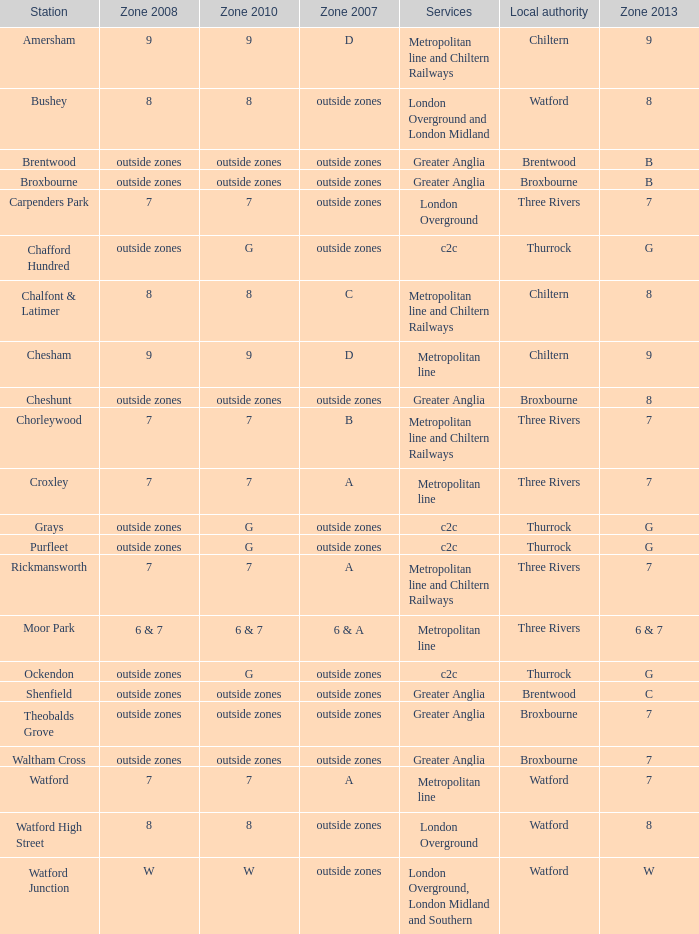I'm looking to parse the entire table for insights. Could you assist me with that? {'header': ['Station', 'Zone 2008', 'Zone 2010', 'Zone 2007', 'Services', 'Local authority', 'Zone 2013'], 'rows': [['Amersham', '9', '9', 'D', 'Metropolitan line and Chiltern Railways', 'Chiltern', '9'], ['Bushey', '8', '8', 'outside zones', 'London Overground and London Midland', 'Watford', '8'], ['Brentwood', 'outside zones', 'outside zones', 'outside zones', 'Greater Anglia', 'Brentwood', 'B'], ['Broxbourne', 'outside zones', 'outside zones', 'outside zones', 'Greater Anglia', 'Broxbourne', 'B'], ['Carpenders Park', '7', '7', 'outside zones', 'London Overground', 'Three Rivers', '7'], ['Chafford Hundred', 'outside zones', 'G', 'outside zones', 'c2c', 'Thurrock', 'G'], ['Chalfont & Latimer', '8', '8', 'C', 'Metropolitan line and Chiltern Railways', 'Chiltern', '8'], ['Chesham', '9', '9', 'D', 'Metropolitan line', 'Chiltern', '9'], ['Cheshunt', 'outside zones', 'outside zones', 'outside zones', 'Greater Anglia', 'Broxbourne', '8'], ['Chorleywood', '7', '7', 'B', 'Metropolitan line and Chiltern Railways', 'Three Rivers', '7'], ['Croxley', '7', '7', 'A', 'Metropolitan line', 'Three Rivers', '7'], ['Grays', 'outside zones', 'G', 'outside zones', 'c2c', 'Thurrock', 'G'], ['Purfleet', 'outside zones', 'G', 'outside zones', 'c2c', 'Thurrock', 'G'], ['Rickmansworth', '7', '7', 'A', 'Metropolitan line and Chiltern Railways', 'Three Rivers', '7'], ['Moor Park', '6 & 7', '6 & 7', '6 & A', 'Metropolitan line', 'Three Rivers', '6 & 7'], ['Ockendon', 'outside zones', 'G', 'outside zones', 'c2c', 'Thurrock', 'G'], ['Shenfield', 'outside zones', 'outside zones', 'outside zones', 'Greater Anglia', 'Brentwood', 'C'], ['Theobalds Grove', 'outside zones', 'outside zones', 'outside zones', 'Greater Anglia', 'Broxbourne', '7'], ['Waltham Cross', 'outside zones', 'outside zones', 'outside zones', 'Greater Anglia', 'Broxbourne', '7'], ['Watford', '7', '7', 'A', 'Metropolitan line', 'Watford', '7'], ['Watford High Street', '8', '8', 'outside zones', 'London Overground', 'Watford', '8'], ['Watford Junction', 'W', 'W', 'outside zones', 'London Overground, London Midland and Southern', 'Watford', 'W']]} Which Station has a Zone 2010 of 7? Carpenders Park, Chorleywood, Croxley, Rickmansworth, Watford. 